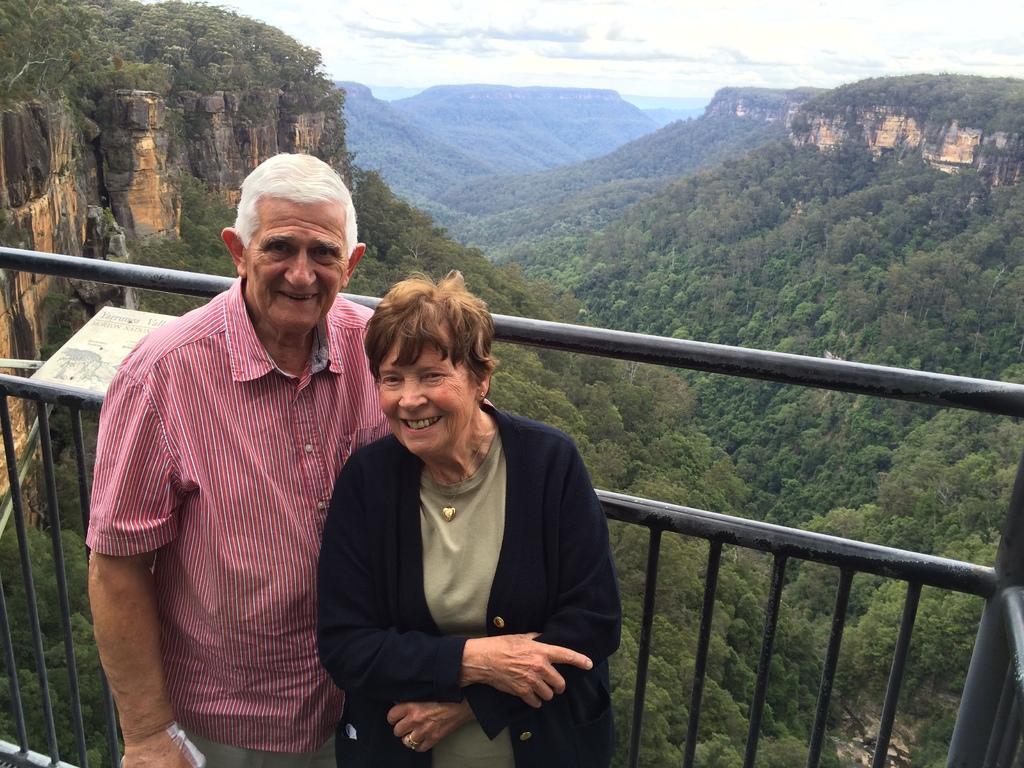Please provide a concise description of this image. There are two persons standing in front a fencing as we can see at the bottom of this image. There are some mountains and trees in the background. There is a cloudy sky at the top of this image. 